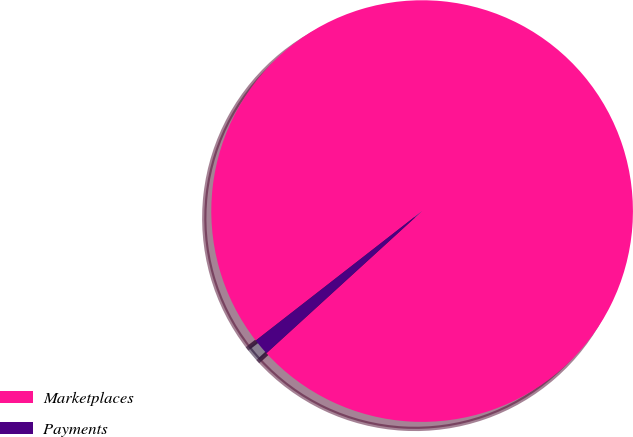Convert chart to OTSL. <chart><loc_0><loc_0><loc_500><loc_500><pie_chart><fcel>Marketplaces<fcel>Payments<nl><fcel>98.75%<fcel>1.25%<nl></chart> 